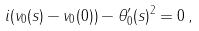Convert formula to latex. <formula><loc_0><loc_0><loc_500><loc_500>i ( v _ { 0 } ( s ) - v _ { 0 } ( 0 ) ) - \theta _ { 0 } ^ { \prime } ( s ) ^ { 2 } = 0 \, ,</formula> 